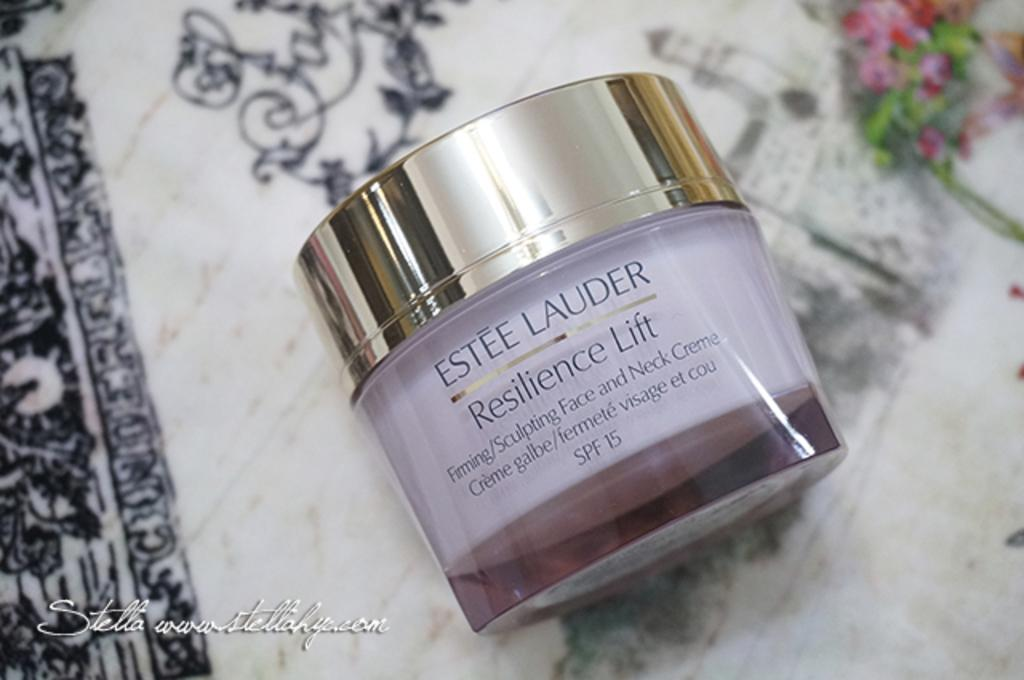<image>
Give a short and clear explanation of the subsequent image. the word Lauder is on the little item 